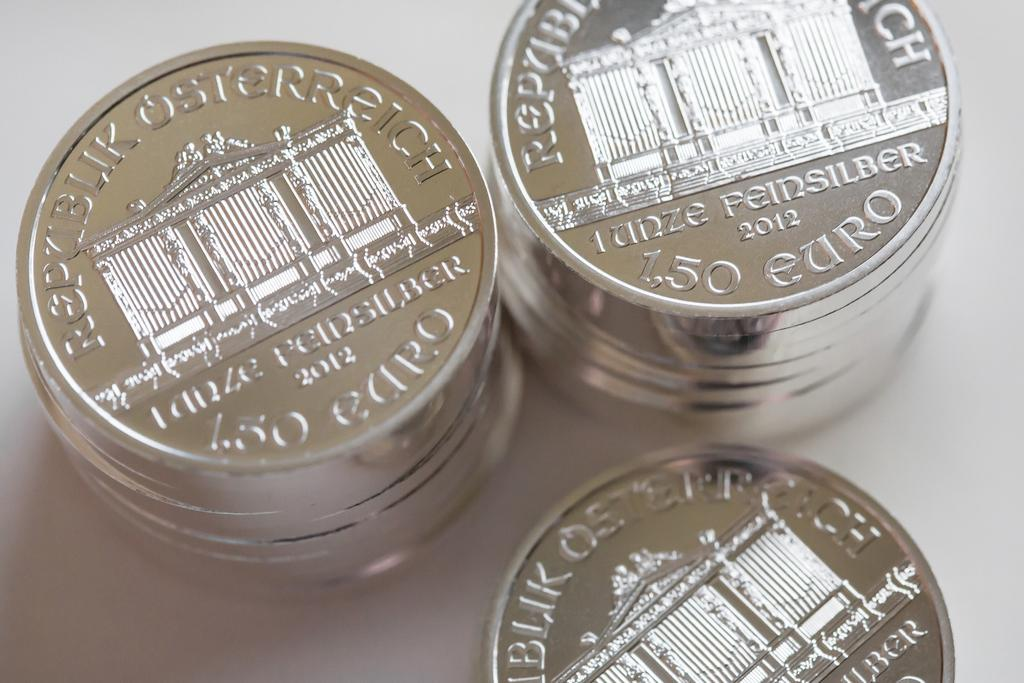<image>
Render a clear and concise summary of the photo. Three stacks of coins are made up of 1,50 euro pieces. 